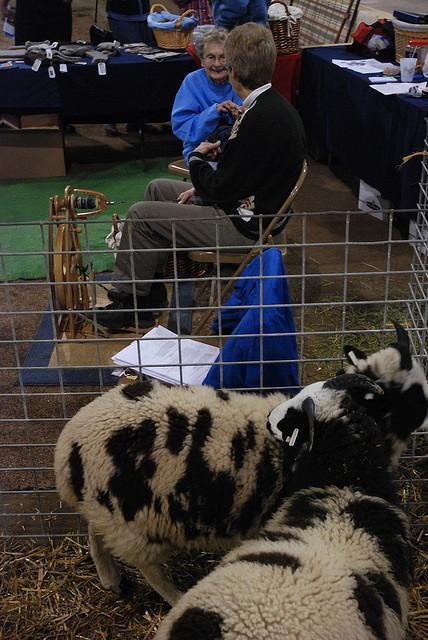How many people are there?
Give a very brief answer. 2. How many chairs are in the photo?
Give a very brief answer. 2. How many sheep can you see?
Give a very brief answer. 2. How many elephants are in the field?
Give a very brief answer. 0. 